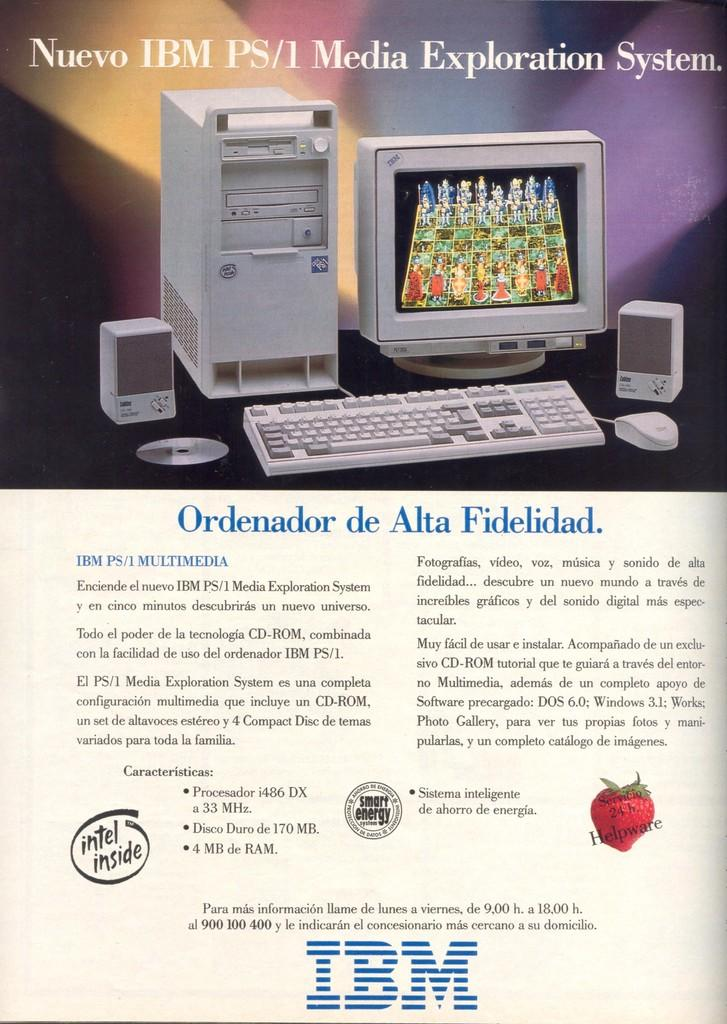<image>
Write a terse but informative summary of the picture. An advertisement details the specifications of the new IBM PS/1 Media Exploration System. 